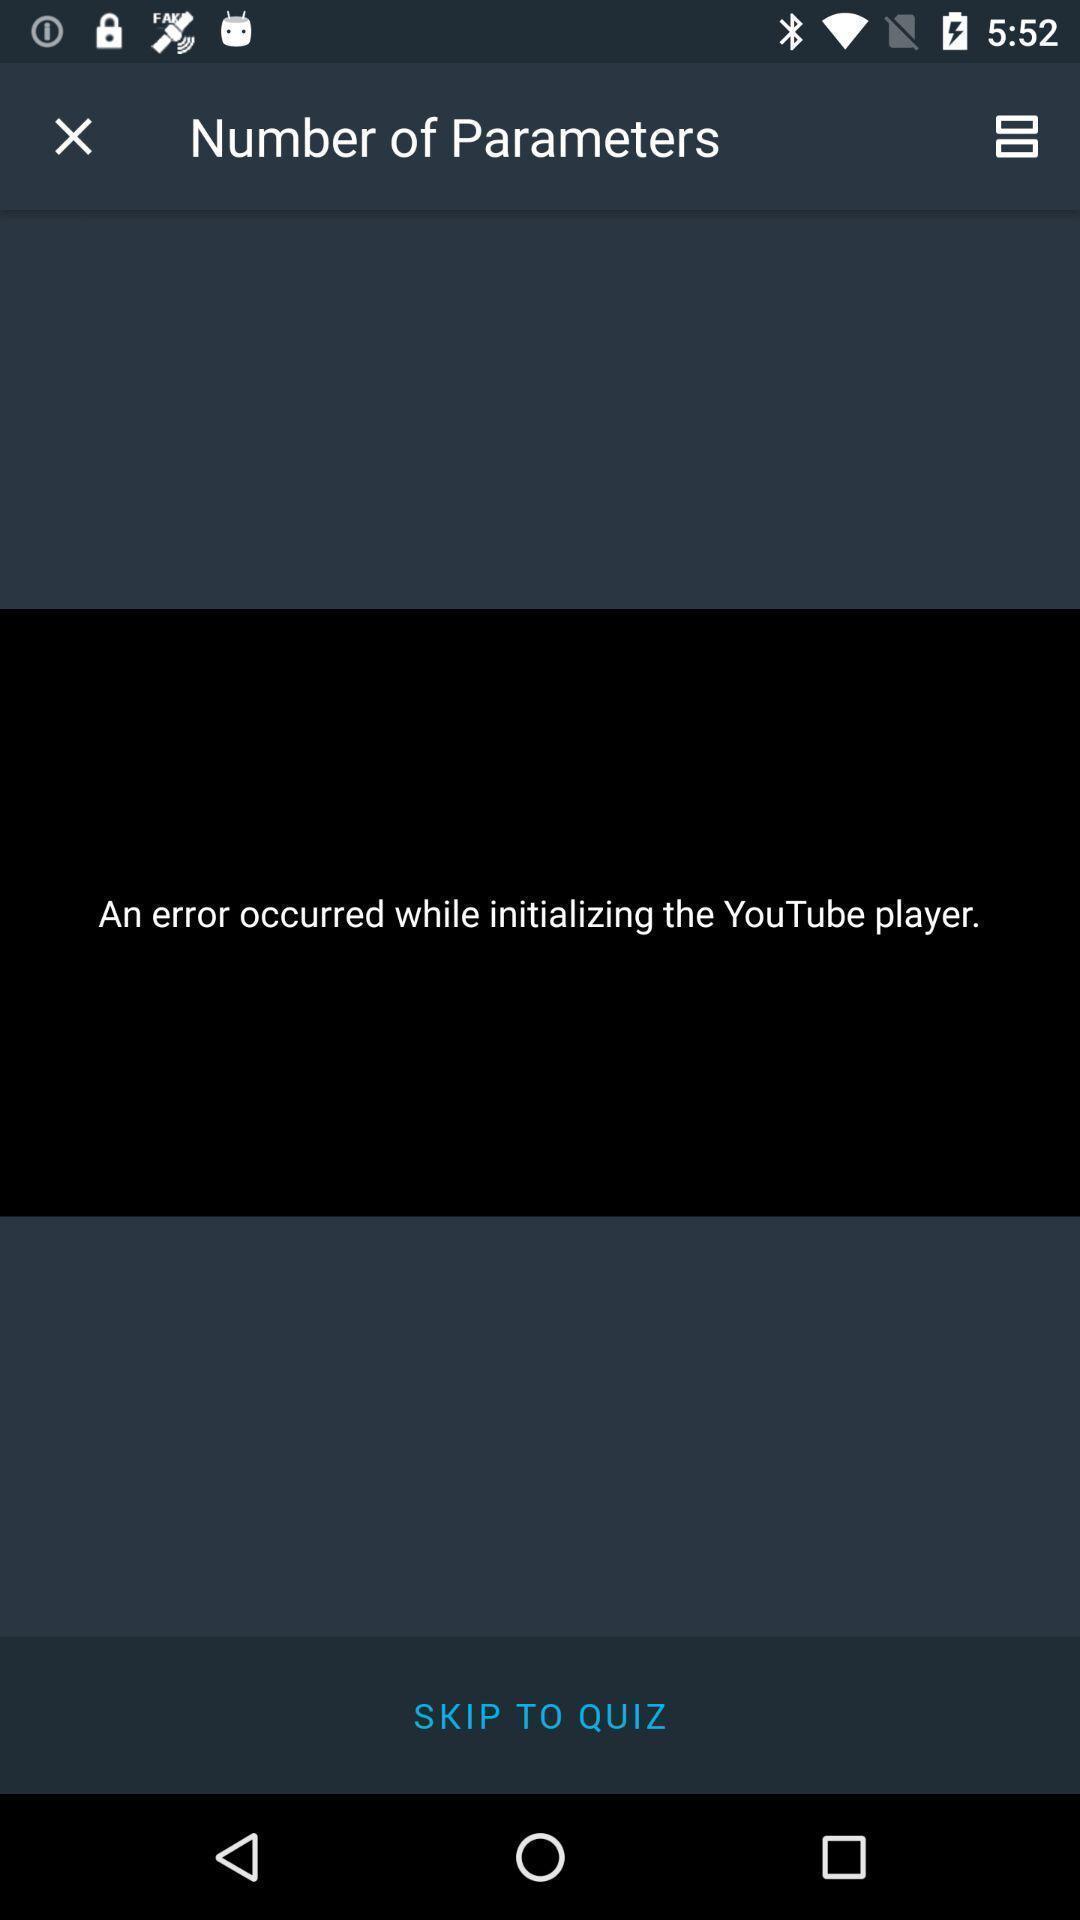Give me a summary of this screen capture. Screen shows an error in a social app. 